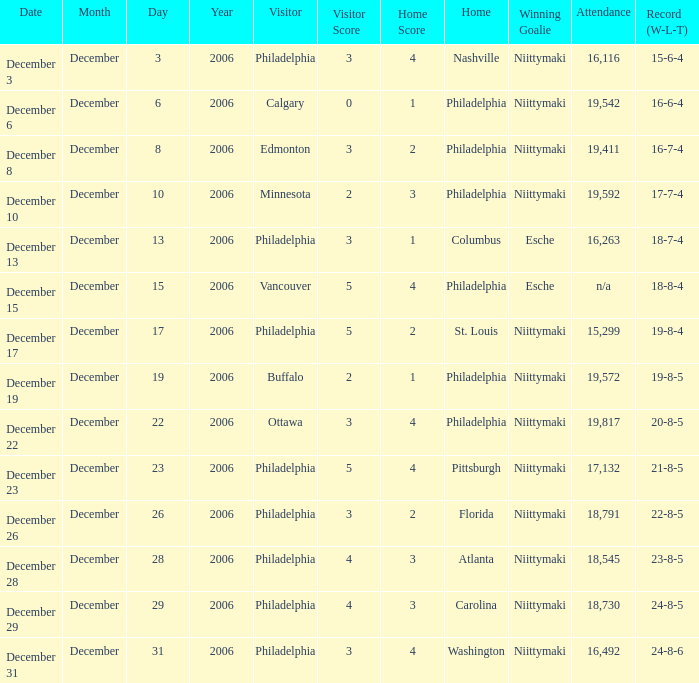What was the decision when the attendance was 19,592? Niittymaki. 